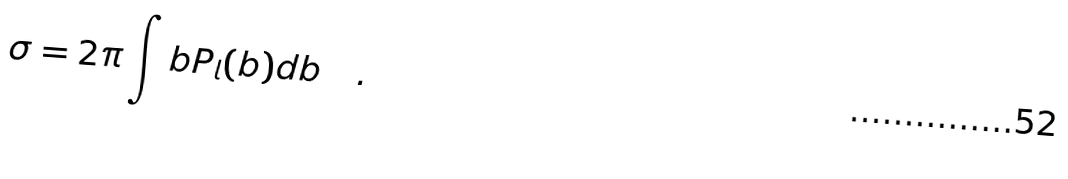Convert formula to latex. <formula><loc_0><loc_0><loc_500><loc_500>\sigma = 2 \pi \int b P _ { l } ( b ) d b \quad .</formula> 